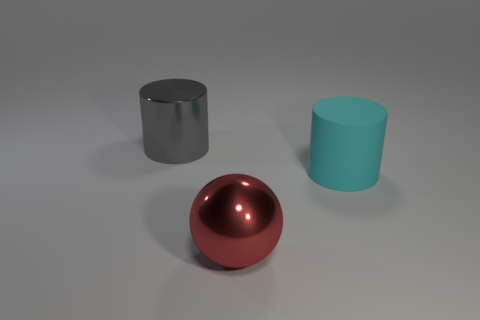Subtract all cyan cylinders. How many cylinders are left? 1 Add 2 big spheres. How many objects exist? 5 Subtract 1 cylinders. How many cylinders are left? 1 Subtract all cylinders. How many objects are left? 1 Subtract all green blocks. How many yellow cylinders are left? 0 Add 1 red metal balls. How many red metal balls exist? 2 Subtract 1 gray cylinders. How many objects are left? 2 Subtract all yellow balls. Subtract all purple cubes. How many balls are left? 1 Subtract all cyan cylinders. Subtract all big red metallic objects. How many objects are left? 1 Add 2 large red shiny balls. How many large red shiny balls are left? 3 